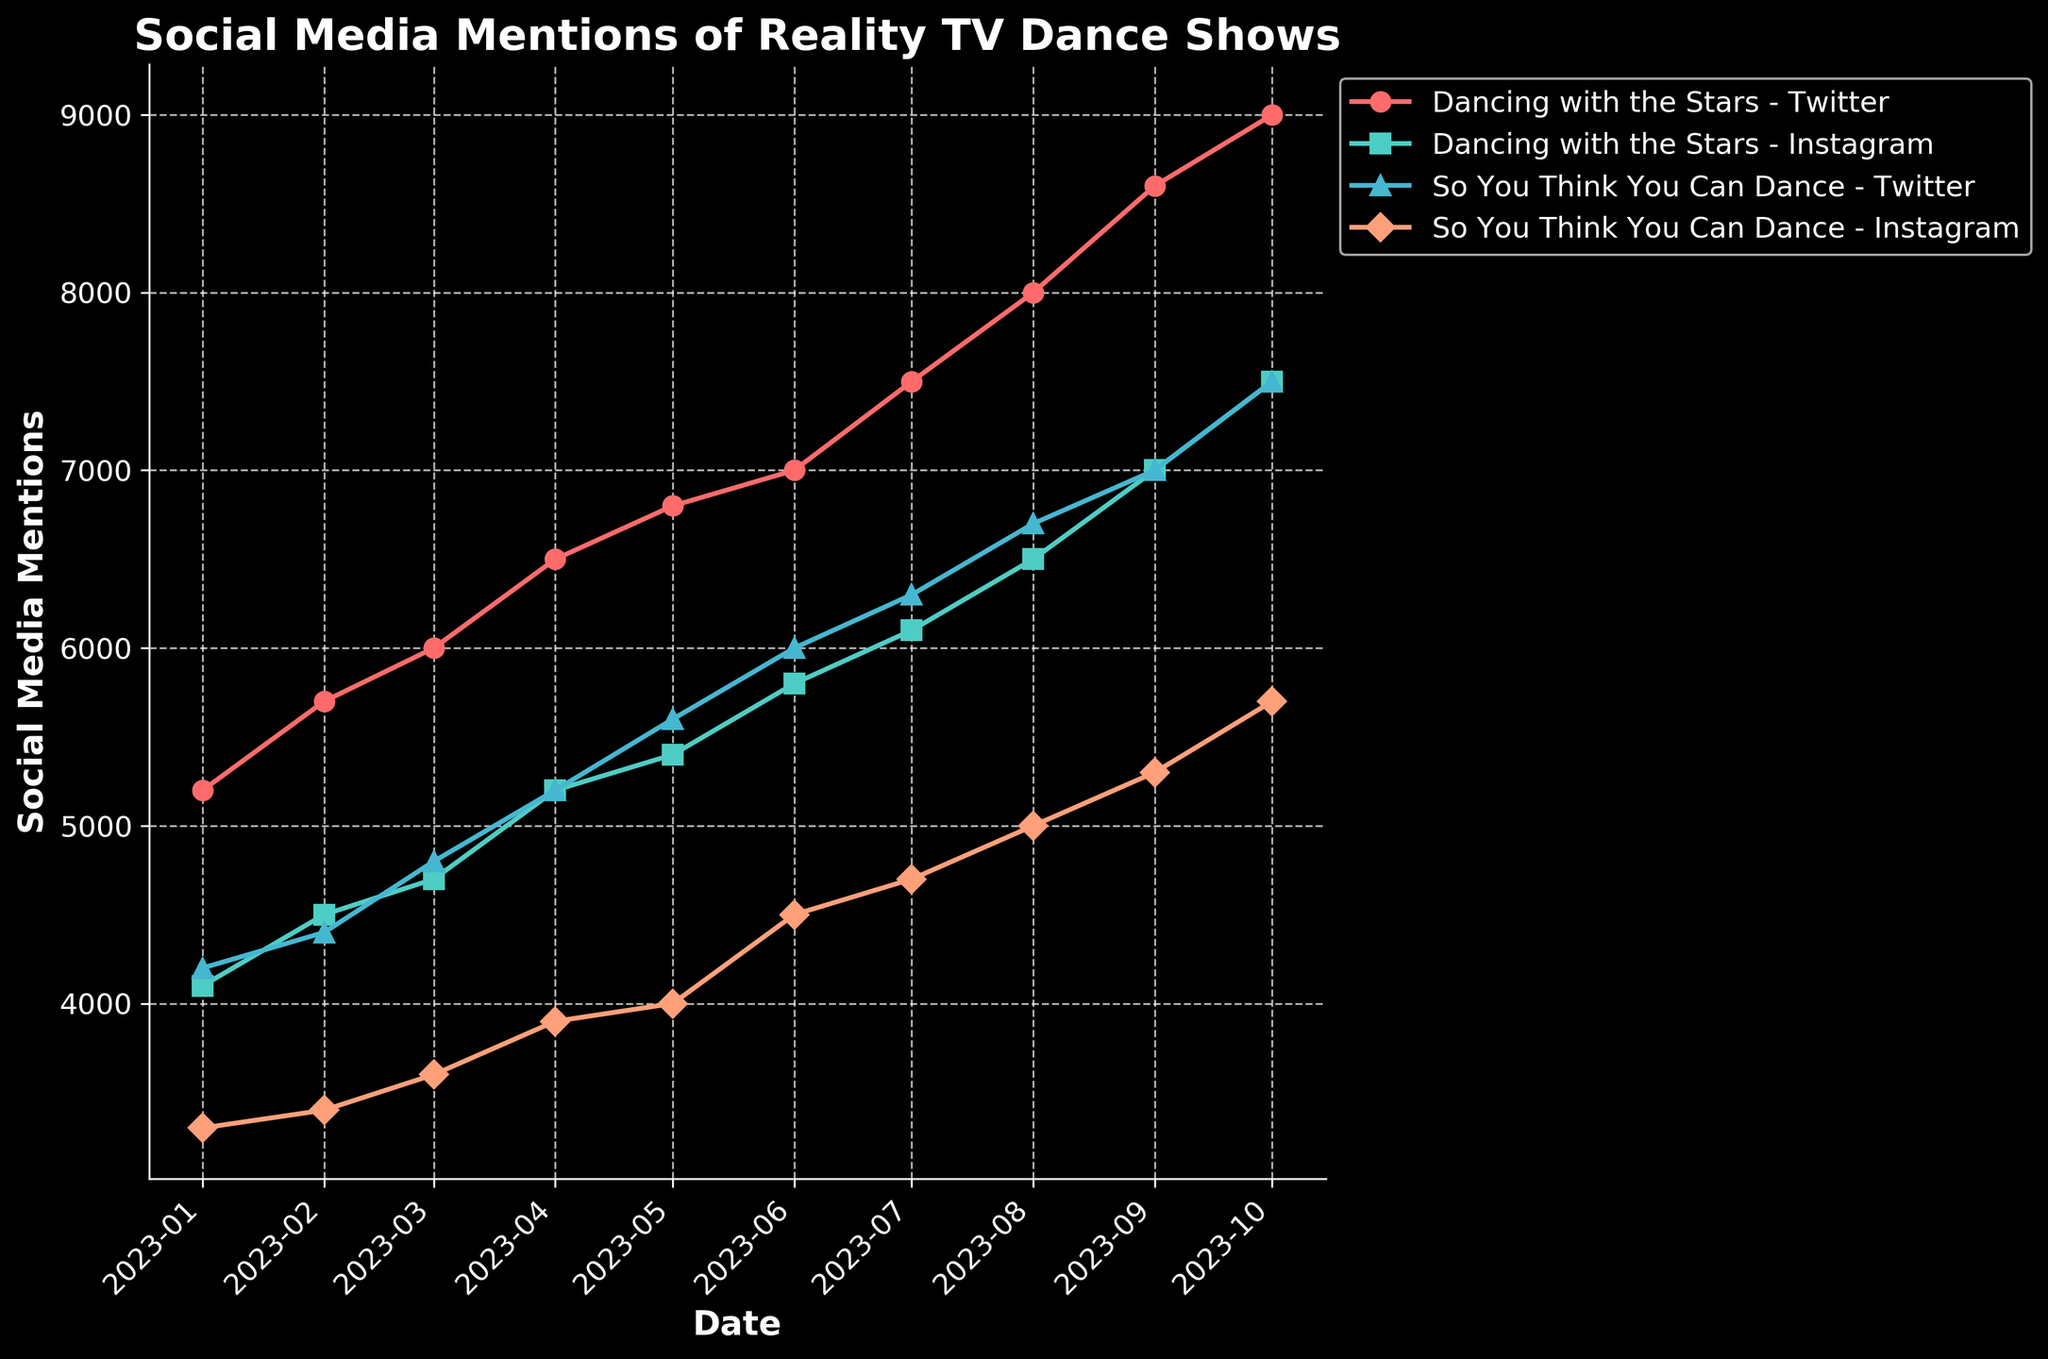What is the title of the plot? The title is usually displayed prominently at the top of the plot. In this case, it is "Social Media Mentions of Reality TV Dance Shows."
Answer: Social Media Mentions of Reality TV Dance Shows What are the two platforms monitored in the figure? The legend on the side of the plot or the labels in the figure show the platforms. Here, we see mentions are tracked on "Twitter" and "Instagram."
Answer: Twitter and Instagram Which show had the highest mentions on Twitter in October 2023? By looking at the data points for October 2023 along the Twitter lines, the highest number of mentions is for "Dancing with the Stars."
Answer: Dancing with the Stars How do the mentions of "So You Think You Can Dance" on Instagram compare from January to October 2023? Observing the Instagram line for "So You Think You Can Dance," we see a steady increase from 3300 mentions in January to 5700 mentions in October.
Answer: Increased from 3300 to 5700 By how much did the mentions of "Dancing with the Stars" on Instagram increase from June to October 2023? Check the mentions of "Dancing with the Stars" on Instagram for June (5800 mentions) and October (7500 mentions). Subtracting the two gives the increase: 7500 - 5800 = 1700.
Answer: 1700 Which platform generally has higher mentions for both shows? By comparing the two platforms' lines for each show, it is evident that Twitter generally has higher mentions for both "Dancing with the Stars" and "So You Think You Can Dance."
Answer: Twitter On which month did "So You Think You Can Dance" on Twitter first reach 6000 mentions? By tracking the timeline for the "So You Think You Can Dance" line on Twitter, it first crosses 6000 mentions in June 2023.
Answer: June 2023 Is there any month where the mentions of "Dancing with the Stars" and "So You Think You Can Dance" on Twitter were equal? We check each month for Twitter data. Both shows have 7500 mentions in October 2023.
Answer: October 2023 What is the trend of mentions for "So You Think You Can Dance" on Twitter from January to October 2023? Follow the line for "So You Think You Can Dance" on Twitter from January (4200 mentions) to October (7500 mentions). The trend shows a consistent increase over time.
Answer: Increasing 